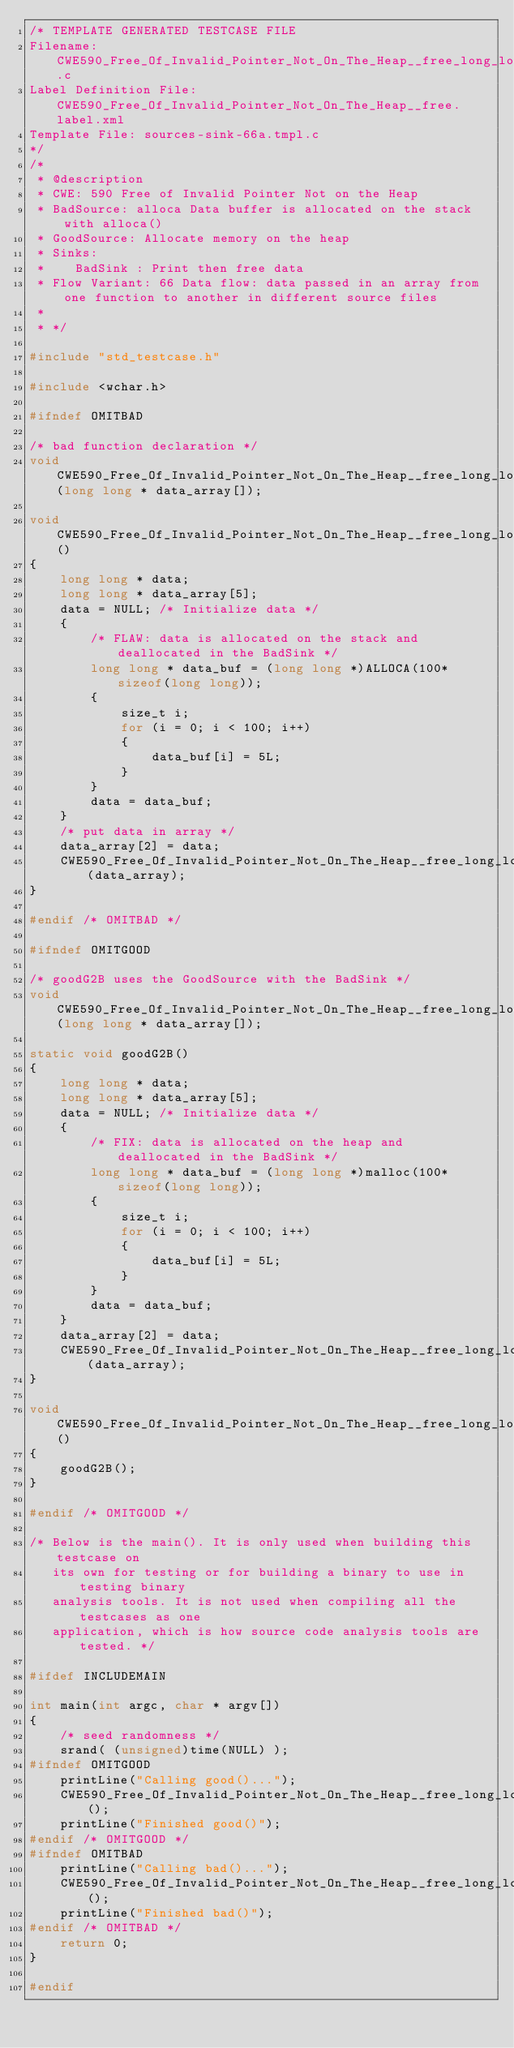Convert code to text. <code><loc_0><loc_0><loc_500><loc_500><_C_>/* TEMPLATE GENERATED TESTCASE FILE
Filename: CWE590_Free_Of_Invalid_Pointer_Not_On_The_Heap__free_long_long_alloca_66a.c
Label Definition File: CWE590_Free_Of_Invalid_Pointer_Not_On_The_Heap__free.label.xml
Template File: sources-sink-66a.tmpl.c
*/
/*
 * @description
 * CWE: 590 Free of Invalid Pointer Not on the Heap
 * BadSource: alloca Data buffer is allocated on the stack with alloca()
 * GoodSource: Allocate memory on the heap
 * Sinks:
 *    BadSink : Print then free data
 * Flow Variant: 66 Data flow: data passed in an array from one function to another in different source files
 *
 * */

#include "std_testcase.h"

#include <wchar.h>

#ifndef OMITBAD

/* bad function declaration */
void CWE590_Free_Of_Invalid_Pointer_Not_On_The_Heap__free_long_long_alloca_66b_bad_sink(long long * data_array[]);

void CWE590_Free_Of_Invalid_Pointer_Not_On_The_Heap__free_long_long_alloca_66_bad()
{
    long long * data;
    long long * data_array[5];
    data = NULL; /* Initialize data */
    {
        /* FLAW: data is allocated on the stack and deallocated in the BadSink */
        long long * data_buf = (long long *)ALLOCA(100*sizeof(long long));
        {
            size_t i;
            for (i = 0; i < 100; i++)
            {
                data_buf[i] = 5L;
            }
        }
        data = data_buf;
    }
    /* put data in array */
    data_array[2] = data;
    CWE590_Free_Of_Invalid_Pointer_Not_On_The_Heap__free_long_long_alloca_66b_bad_sink(data_array);
}

#endif /* OMITBAD */

#ifndef OMITGOOD

/* goodG2B uses the GoodSource with the BadSink */
void CWE590_Free_Of_Invalid_Pointer_Not_On_The_Heap__free_long_long_alloca_66b_goodG2B_sink(long long * data_array[]);

static void goodG2B()
{
    long long * data;
    long long * data_array[5];
    data = NULL; /* Initialize data */
    {
        /* FIX: data is allocated on the heap and deallocated in the BadSink */
        long long * data_buf = (long long *)malloc(100*sizeof(long long));
        {
            size_t i;
            for (i = 0; i < 100; i++)
            {
                data_buf[i] = 5L;
            }
        }
        data = data_buf;
    }
    data_array[2] = data;
    CWE590_Free_Of_Invalid_Pointer_Not_On_The_Heap__free_long_long_alloca_66b_goodG2B_sink(data_array);
}

void CWE590_Free_Of_Invalid_Pointer_Not_On_The_Heap__free_long_long_alloca_66_good()
{
    goodG2B();
}

#endif /* OMITGOOD */

/* Below is the main(). It is only used when building this testcase on
   its own for testing or for building a binary to use in testing binary
   analysis tools. It is not used when compiling all the testcases as one
   application, which is how source code analysis tools are tested. */

#ifdef INCLUDEMAIN

int main(int argc, char * argv[])
{
    /* seed randomness */
    srand( (unsigned)time(NULL) );
#ifndef OMITGOOD
    printLine("Calling good()...");
    CWE590_Free_Of_Invalid_Pointer_Not_On_The_Heap__free_long_long_alloca_66_good();
    printLine("Finished good()");
#endif /* OMITGOOD */
#ifndef OMITBAD
    printLine("Calling bad()...");
    CWE590_Free_Of_Invalid_Pointer_Not_On_The_Heap__free_long_long_alloca_66_bad();
    printLine("Finished bad()");
#endif /* OMITBAD */
    return 0;
}

#endif
</code> 